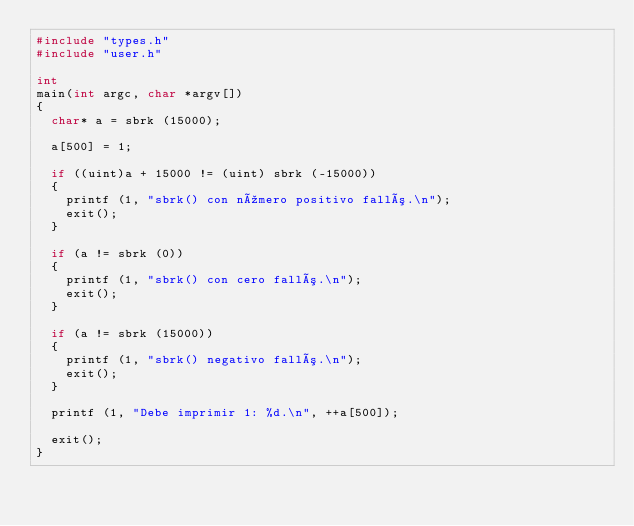<code> <loc_0><loc_0><loc_500><loc_500><_C_>#include "types.h"
#include "user.h"

int
main(int argc, char *argv[])
{
  char* a = sbrk (15000);

  a[500] = 1;

  if ((uint)a + 15000 != (uint) sbrk (-15000))
  {
    printf (1, "sbrk() con número positivo falló.\n");
    exit();
  }

  if (a != sbrk (0))
  {
    printf (1, "sbrk() con cero falló.\n");
    exit();
  }

  if (a != sbrk (15000))
  {
    printf (1, "sbrk() negativo falló.\n");
    exit();
  }

  printf (1, "Debe imprimir 1: %d.\n", ++a[500]);

  exit();
}
</code> 